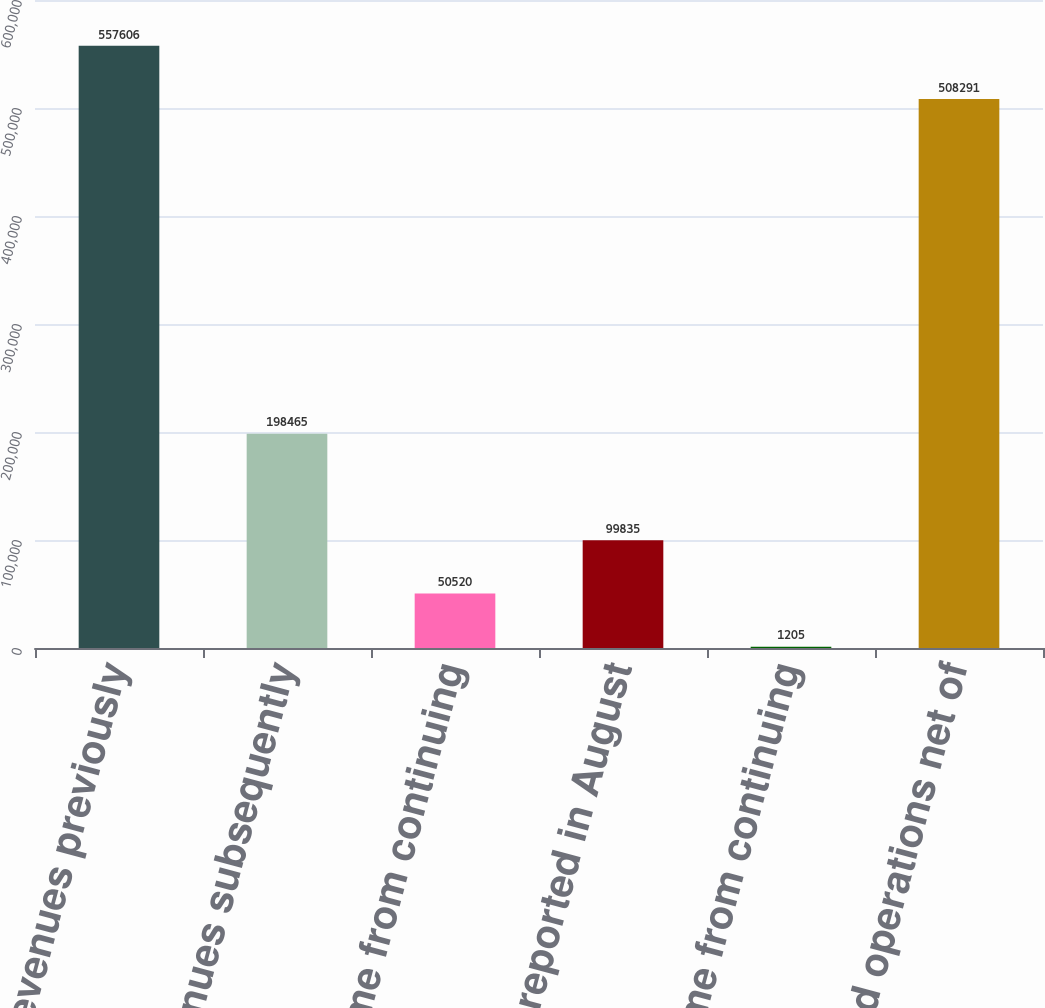Convert chart to OTSL. <chart><loc_0><loc_0><loc_500><loc_500><bar_chart><fcel>Total revenues previously<fcel>Total revenues subsequently<fcel>Income from continuing<fcel>previously reported in August<fcel>(Loss) income from continuing<fcel>Discontinued operations net of<nl><fcel>557606<fcel>198465<fcel>50520<fcel>99835<fcel>1205<fcel>508291<nl></chart> 